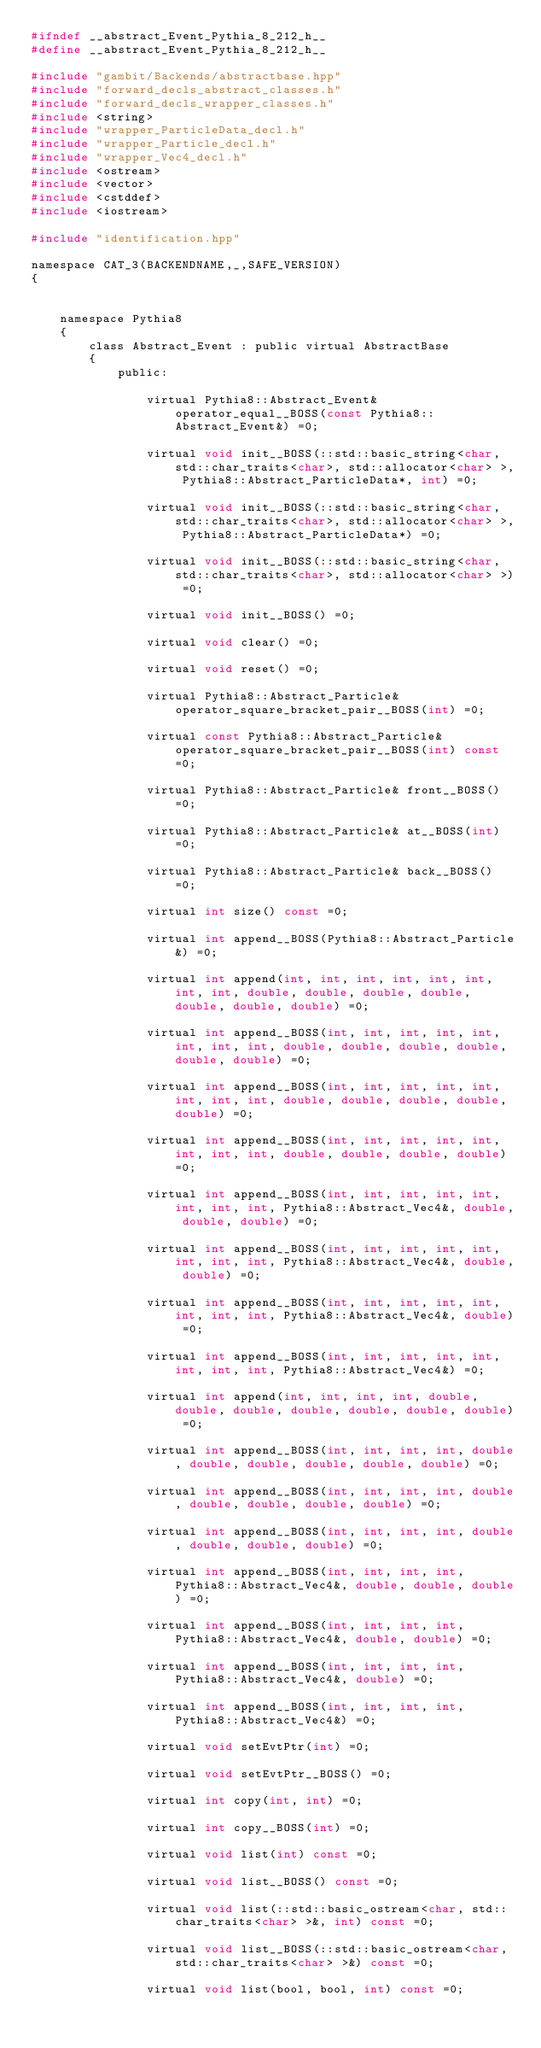<code> <loc_0><loc_0><loc_500><loc_500><_C_>#ifndef __abstract_Event_Pythia_8_212_h__
#define __abstract_Event_Pythia_8_212_h__

#include "gambit/Backends/abstractbase.hpp"
#include "forward_decls_abstract_classes.h"
#include "forward_decls_wrapper_classes.h"
#include <string>
#include "wrapper_ParticleData_decl.h"
#include "wrapper_Particle_decl.h"
#include "wrapper_Vec4_decl.h"
#include <ostream>
#include <vector>
#include <cstddef>
#include <iostream>

#include "identification.hpp"

namespace CAT_3(BACKENDNAME,_,SAFE_VERSION)
{
    
    
    namespace Pythia8
    {
        class Abstract_Event : public virtual AbstractBase
        {
            public:
    
                virtual Pythia8::Abstract_Event& operator_equal__BOSS(const Pythia8::Abstract_Event&) =0;
    
                virtual void init__BOSS(::std::basic_string<char, std::char_traits<char>, std::allocator<char> >, Pythia8::Abstract_ParticleData*, int) =0;
    
                virtual void init__BOSS(::std::basic_string<char, std::char_traits<char>, std::allocator<char> >, Pythia8::Abstract_ParticleData*) =0;
    
                virtual void init__BOSS(::std::basic_string<char, std::char_traits<char>, std::allocator<char> >) =0;
    
                virtual void init__BOSS() =0;
    
                virtual void clear() =0;
    
                virtual void reset() =0;
    
                virtual Pythia8::Abstract_Particle& operator_square_bracket_pair__BOSS(int) =0;
    
                virtual const Pythia8::Abstract_Particle& operator_square_bracket_pair__BOSS(int) const =0;
    
                virtual Pythia8::Abstract_Particle& front__BOSS() =0;
    
                virtual Pythia8::Abstract_Particle& at__BOSS(int) =0;
    
                virtual Pythia8::Abstract_Particle& back__BOSS() =0;
    
                virtual int size() const =0;
    
                virtual int append__BOSS(Pythia8::Abstract_Particle&) =0;
    
                virtual int append(int, int, int, int, int, int, int, int, double, double, double, double, double, double, double) =0;
    
                virtual int append__BOSS(int, int, int, int, int, int, int, int, double, double, double, double, double, double) =0;
    
                virtual int append__BOSS(int, int, int, int, int, int, int, int, double, double, double, double, double) =0;
    
                virtual int append__BOSS(int, int, int, int, int, int, int, int, double, double, double, double) =0;
    
                virtual int append__BOSS(int, int, int, int, int, int, int, int, Pythia8::Abstract_Vec4&, double, double, double) =0;
    
                virtual int append__BOSS(int, int, int, int, int, int, int, int, Pythia8::Abstract_Vec4&, double, double) =0;
    
                virtual int append__BOSS(int, int, int, int, int, int, int, int, Pythia8::Abstract_Vec4&, double) =0;
    
                virtual int append__BOSS(int, int, int, int, int, int, int, int, Pythia8::Abstract_Vec4&) =0;
    
                virtual int append(int, int, int, int, double, double, double, double, double, double, double) =0;
    
                virtual int append__BOSS(int, int, int, int, double, double, double, double, double, double) =0;
    
                virtual int append__BOSS(int, int, int, int, double, double, double, double, double) =0;
    
                virtual int append__BOSS(int, int, int, int, double, double, double, double) =0;
    
                virtual int append__BOSS(int, int, int, int, Pythia8::Abstract_Vec4&, double, double, double) =0;
    
                virtual int append__BOSS(int, int, int, int, Pythia8::Abstract_Vec4&, double, double) =0;
    
                virtual int append__BOSS(int, int, int, int, Pythia8::Abstract_Vec4&, double) =0;
    
                virtual int append__BOSS(int, int, int, int, Pythia8::Abstract_Vec4&) =0;
    
                virtual void setEvtPtr(int) =0;
    
                virtual void setEvtPtr__BOSS() =0;
    
                virtual int copy(int, int) =0;
    
                virtual int copy__BOSS(int) =0;
    
                virtual void list(int) const =0;
    
                virtual void list__BOSS() const =0;
    
                virtual void list(::std::basic_ostream<char, std::char_traits<char> >&, int) const =0;
    
                virtual void list__BOSS(::std::basic_ostream<char, std::char_traits<char> >&) const =0;
    
                virtual void list(bool, bool, int) const =0;
    </code> 